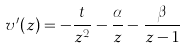<formula> <loc_0><loc_0><loc_500><loc_500>v ^ { \prime } ( z ) = - \frac { t } { z ^ { 2 } } - \frac { \alpha } { z } - \frac { \beta } { z - 1 }</formula> 